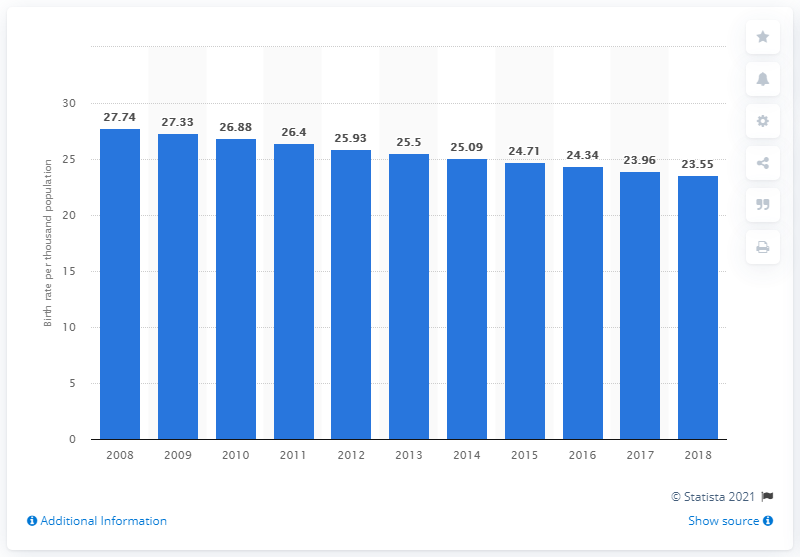Draw attention to some important aspects in this diagram. In 2018, the crude birth rate in Laos was 23.55. 